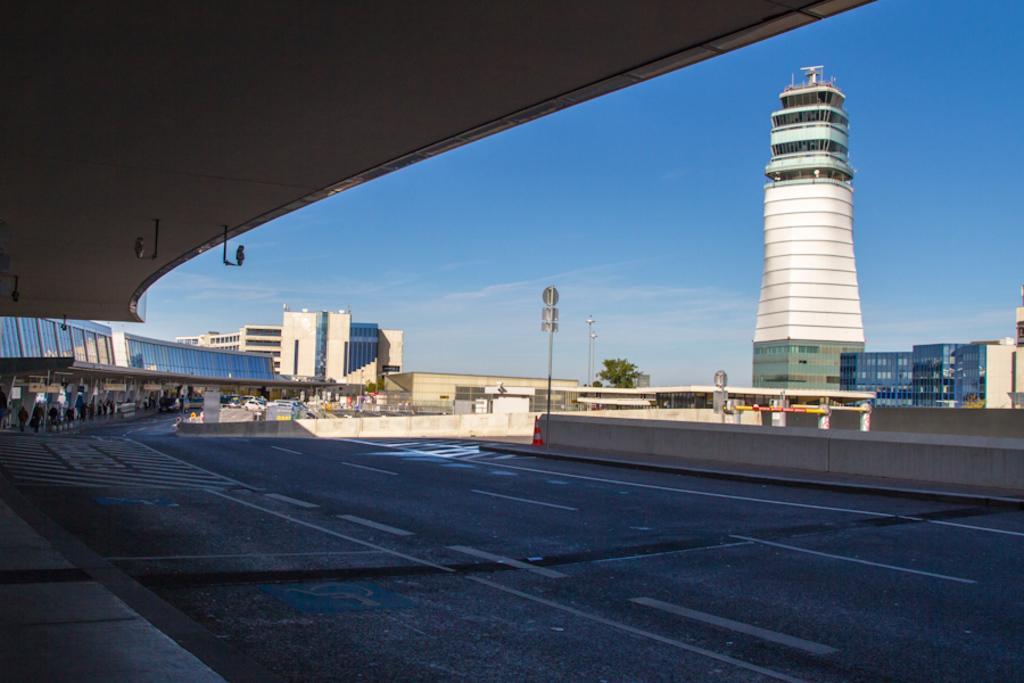Please provide a concise description of this image. There is a road. On the left side of the road there are buildings. On the ride side there is a wall. Near to that there is a traffic cone. There are poles. In the back there are many buildings. In the background there is tree and sky. 